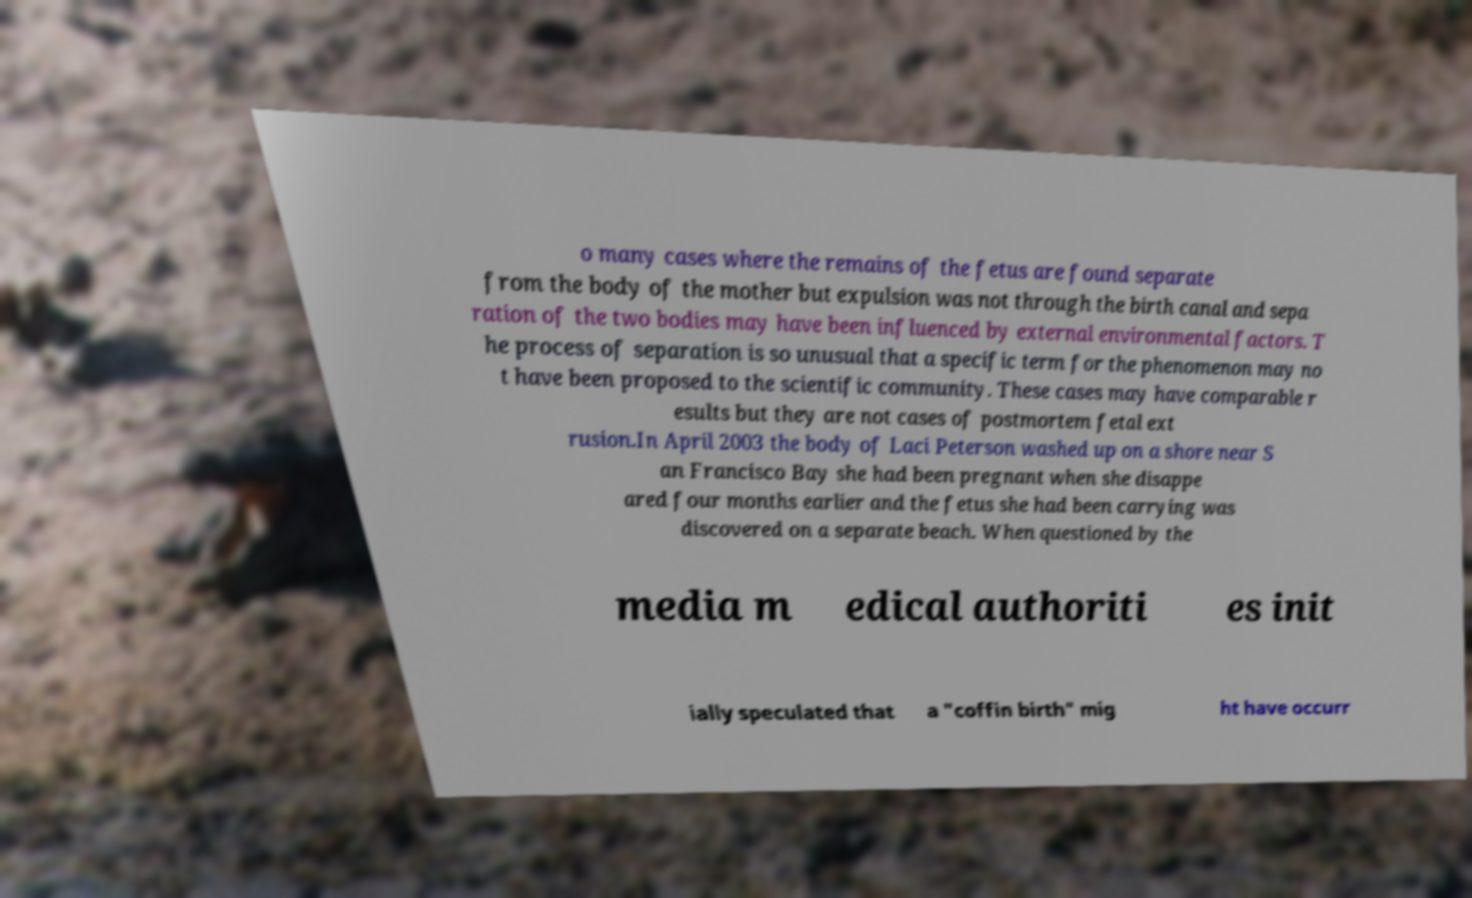Could you assist in decoding the text presented in this image and type it out clearly? o many cases where the remains of the fetus are found separate from the body of the mother but expulsion was not through the birth canal and sepa ration of the two bodies may have been influenced by external environmental factors. T he process of separation is so unusual that a specific term for the phenomenon may no t have been proposed to the scientific community. These cases may have comparable r esults but they are not cases of postmortem fetal ext rusion.In April 2003 the body of Laci Peterson washed up on a shore near S an Francisco Bay she had been pregnant when she disappe ared four months earlier and the fetus she had been carrying was discovered on a separate beach. When questioned by the media m edical authoriti es init ially speculated that a "coffin birth" mig ht have occurr 